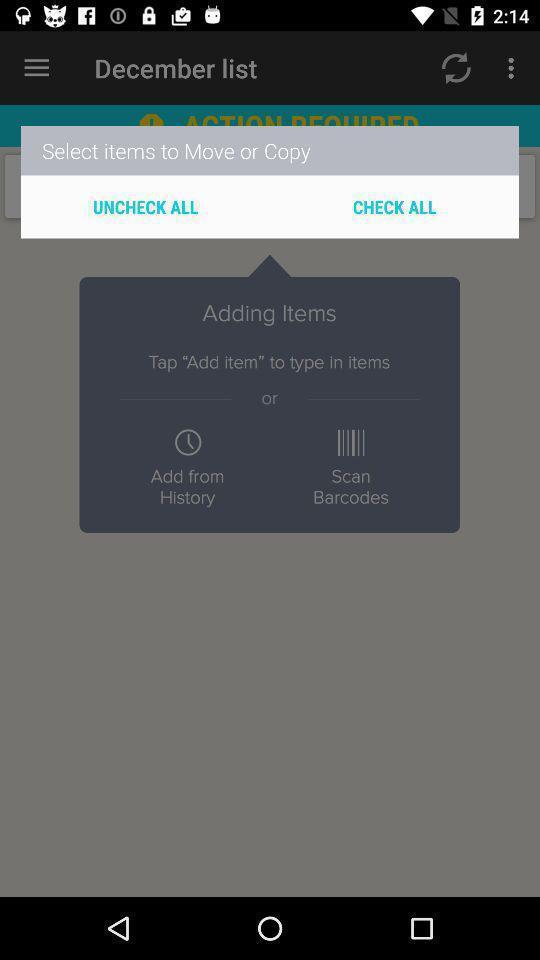Describe this image in words. Pop-up showing the items to copy or paste. 